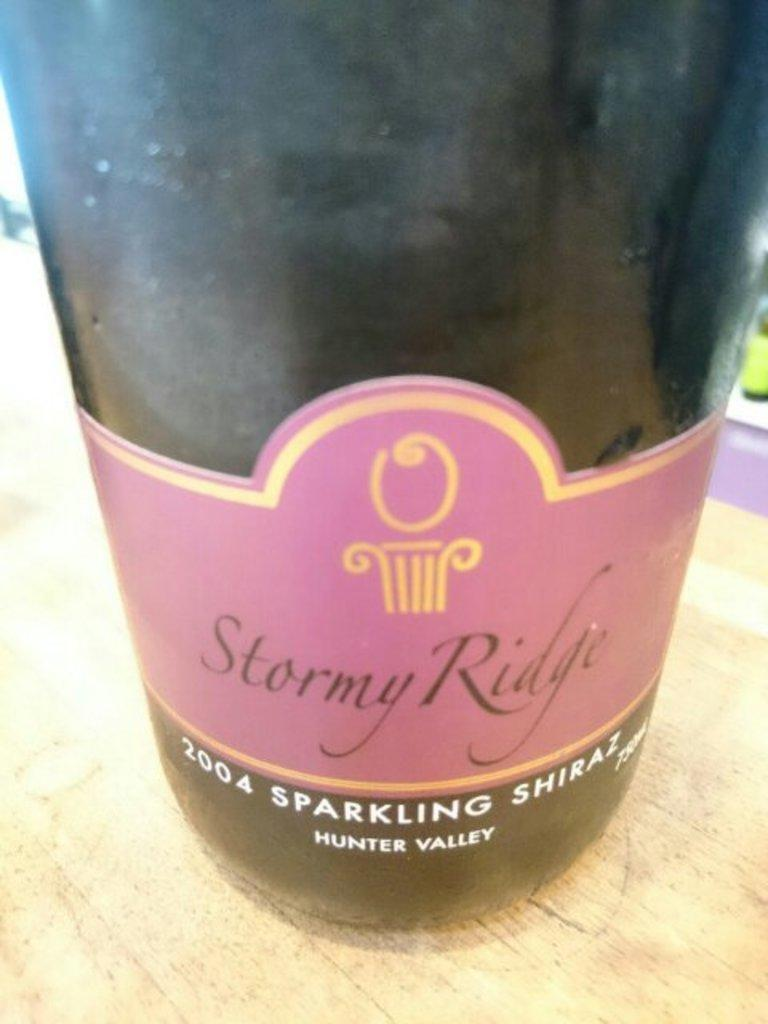<image>
Share a concise interpretation of the image provided. A bottle of Stormy Ridge 2004 sparkling shiraz from hunter valley sits on a table. 